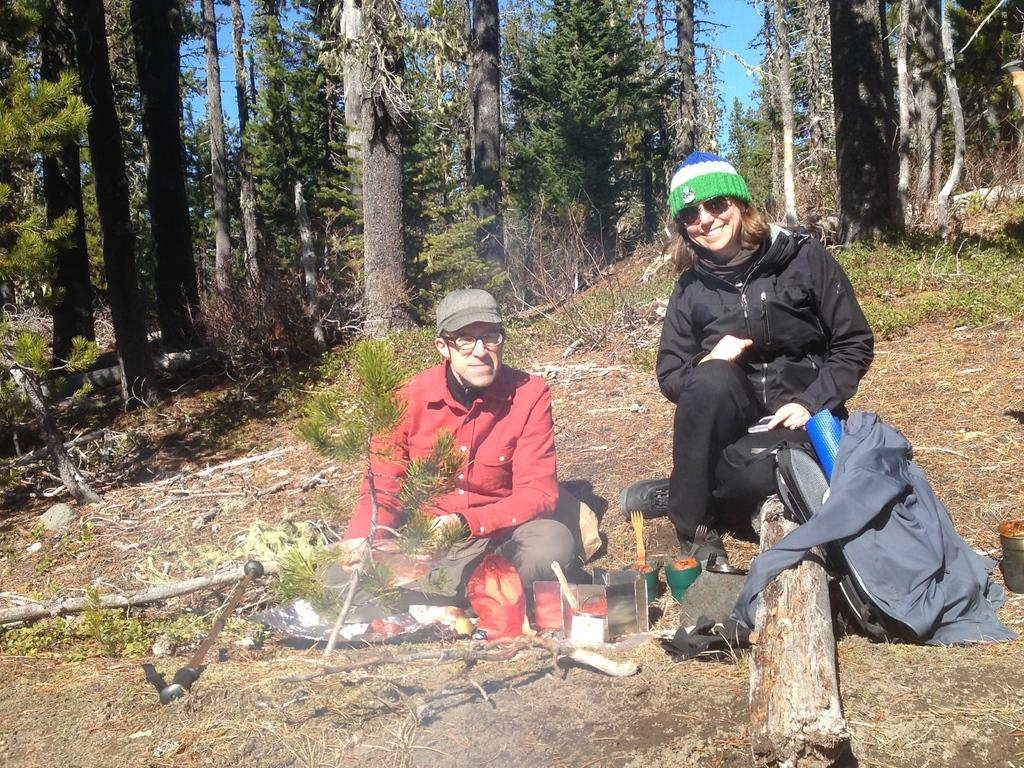How many persons are sitting on the floor in the image? There are two persons sitting on the floor in the image. What objects are in front of the persons? There are bowls, forks, and papers in front of the persons. What type of vegetation is visible in the image? There is a stem of a tree with leaves present in the image. What additional items can be seen in the image? There is a bag, a wooden plank, and trees visible at the top of the image. What is visible in the sky in the image? The sky is visible at the top of the image. What is the tendency of the fangs in the image? There are no fangs present in the image. 